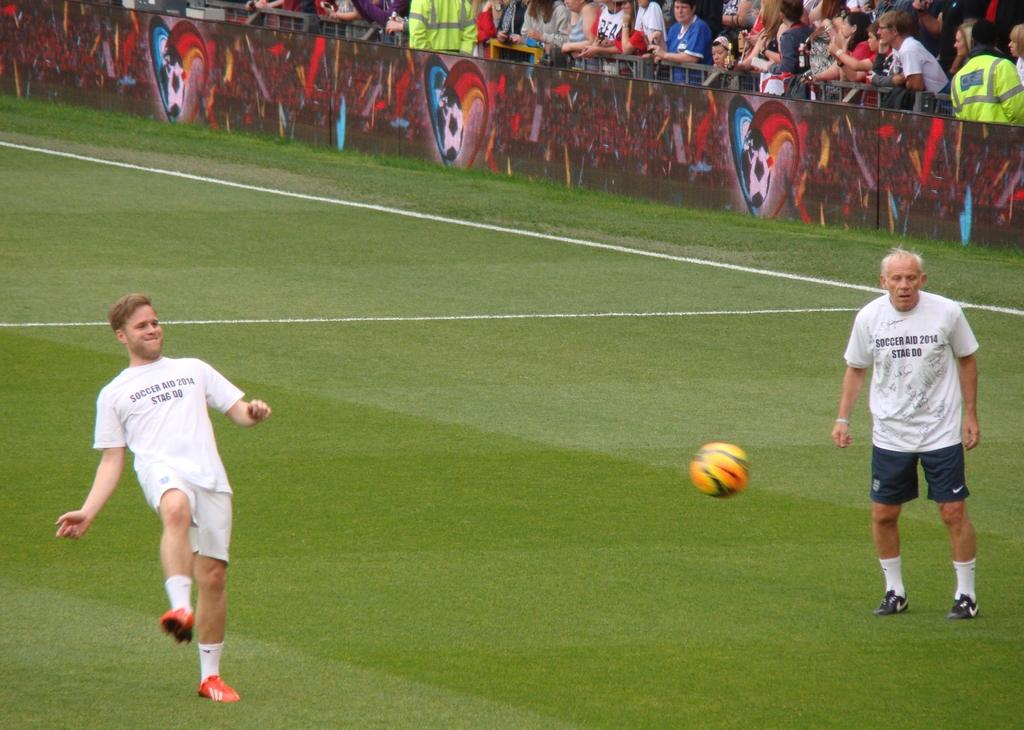<image>
Provide a brief description of the given image. A person is with their leg lifted wearing a shirt that says Soccer Aid 2014 Stag Do 